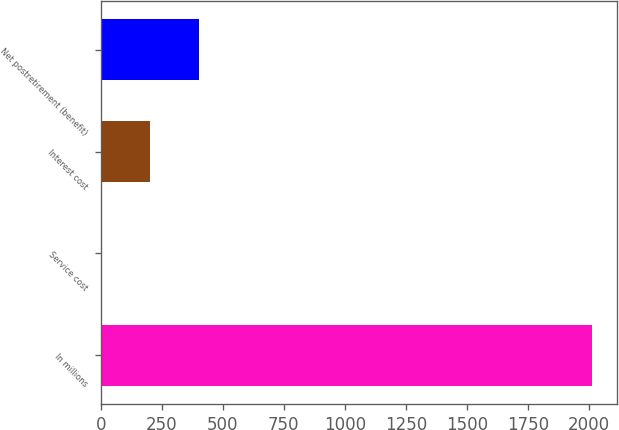Convert chart. <chart><loc_0><loc_0><loc_500><loc_500><bar_chart><fcel>In millions<fcel>Service cost<fcel>Interest cost<fcel>Net postretirement (benefit)<nl><fcel>2015<fcel>1<fcel>202.4<fcel>403.8<nl></chart> 